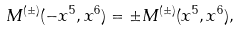<formula> <loc_0><loc_0><loc_500><loc_500>M ^ { ( \pm ) } ( - x ^ { 5 } , x ^ { 6 } ) = \pm M ^ { ( \pm ) } ( x ^ { 5 } , x ^ { 6 } ) ,</formula> 